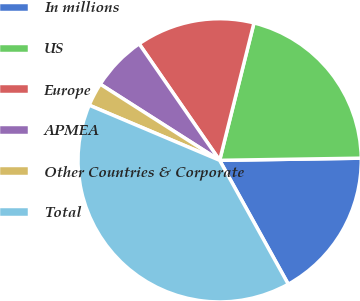Convert chart. <chart><loc_0><loc_0><loc_500><loc_500><pie_chart><fcel>In millions<fcel>US<fcel>Europe<fcel>APMEA<fcel>Other Countries & Corporate<fcel>Total<nl><fcel>17.19%<fcel>20.86%<fcel>13.52%<fcel>6.34%<fcel>2.67%<fcel>39.42%<nl></chart> 